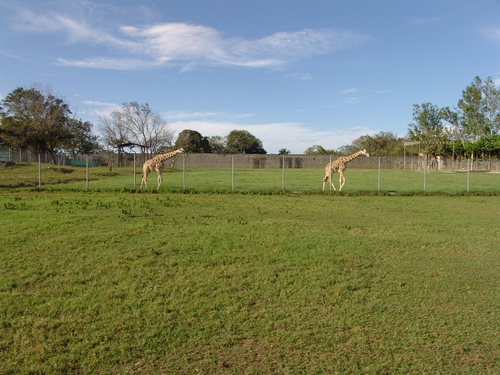<image>What noise do the animals in the field make? It is unknown what noise the animals in the field make. The noises could be anything from grunt, spitting, growl to roar. What noise do the animals in the field make? I am not sure what noise the animals in the field make. It can be nothing, grunt, spitting, growl, roar, or grunts. 